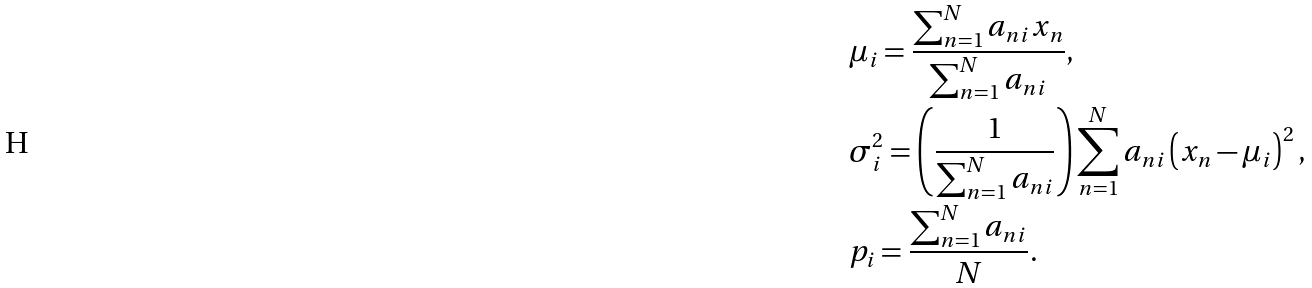<formula> <loc_0><loc_0><loc_500><loc_500>& \mu _ { i } = \frac { \sum _ { n = 1 } ^ { N } a _ { n i } x _ { n } } { \sum _ { n = 1 } ^ { N } a _ { n i } } , \\ & \sigma _ { i } ^ { 2 } = \left ( \frac { 1 } { \sum _ { n = 1 } ^ { N } a _ { n i } } \right ) \sum _ { n = 1 } ^ { N } a _ { n i } \left ( x _ { n } - \mu _ { i } \right ) ^ { 2 } , \\ & p _ { i } = \frac { \sum _ { n = 1 } ^ { N } a _ { n i } } { N } .</formula> 